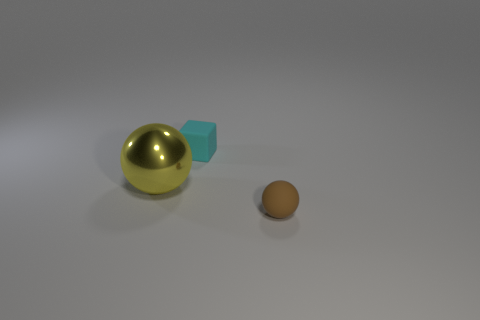What number of spheres are big yellow shiny things or brown matte things?
Your answer should be compact. 2. Is the number of big yellow metal things to the right of the tiny brown rubber object less than the number of things in front of the cyan thing?
Offer a terse response. Yes. What number of objects are either tiny balls that are to the right of the large thing or small yellow cylinders?
Provide a short and direct response. 1. There is a small rubber thing to the right of the tiny thing left of the small ball; what is its shape?
Make the answer very short. Sphere. Is there a ball of the same size as the cyan thing?
Your answer should be compact. Yes. Are there more big metallic balls than small green things?
Keep it short and to the point. Yes. Is the size of the rubber object that is behind the rubber ball the same as the ball behind the small ball?
Provide a succinct answer. No. What number of objects are both on the right side of the metallic ball and on the left side of the brown ball?
Your answer should be very brief. 1. There is another object that is the same shape as the metallic thing; what is its color?
Offer a very short reply. Brown. Is the number of green metal cubes less than the number of small cyan objects?
Provide a short and direct response. Yes. 